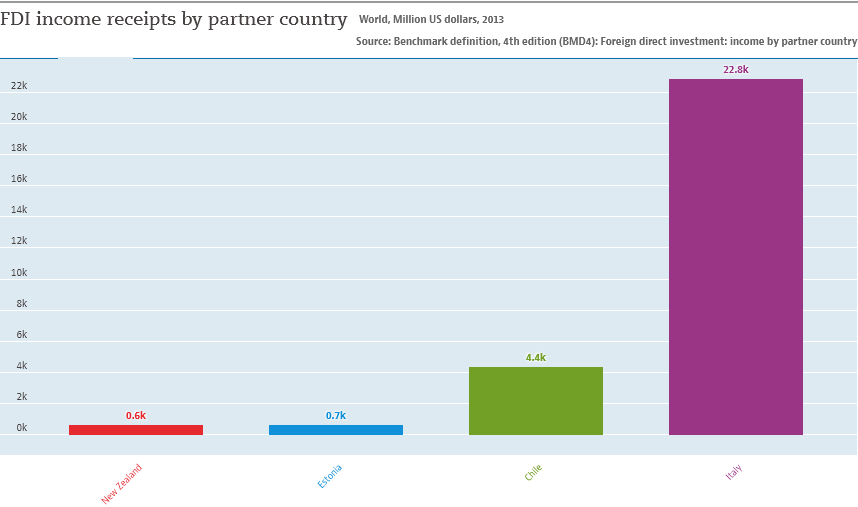Specify some key components in this picture. The distribution of Italy and Chile differ significantly, with Italy having a higher average of 18.4 and Chile having a lower average. The value of the purple bar is 22.8. 